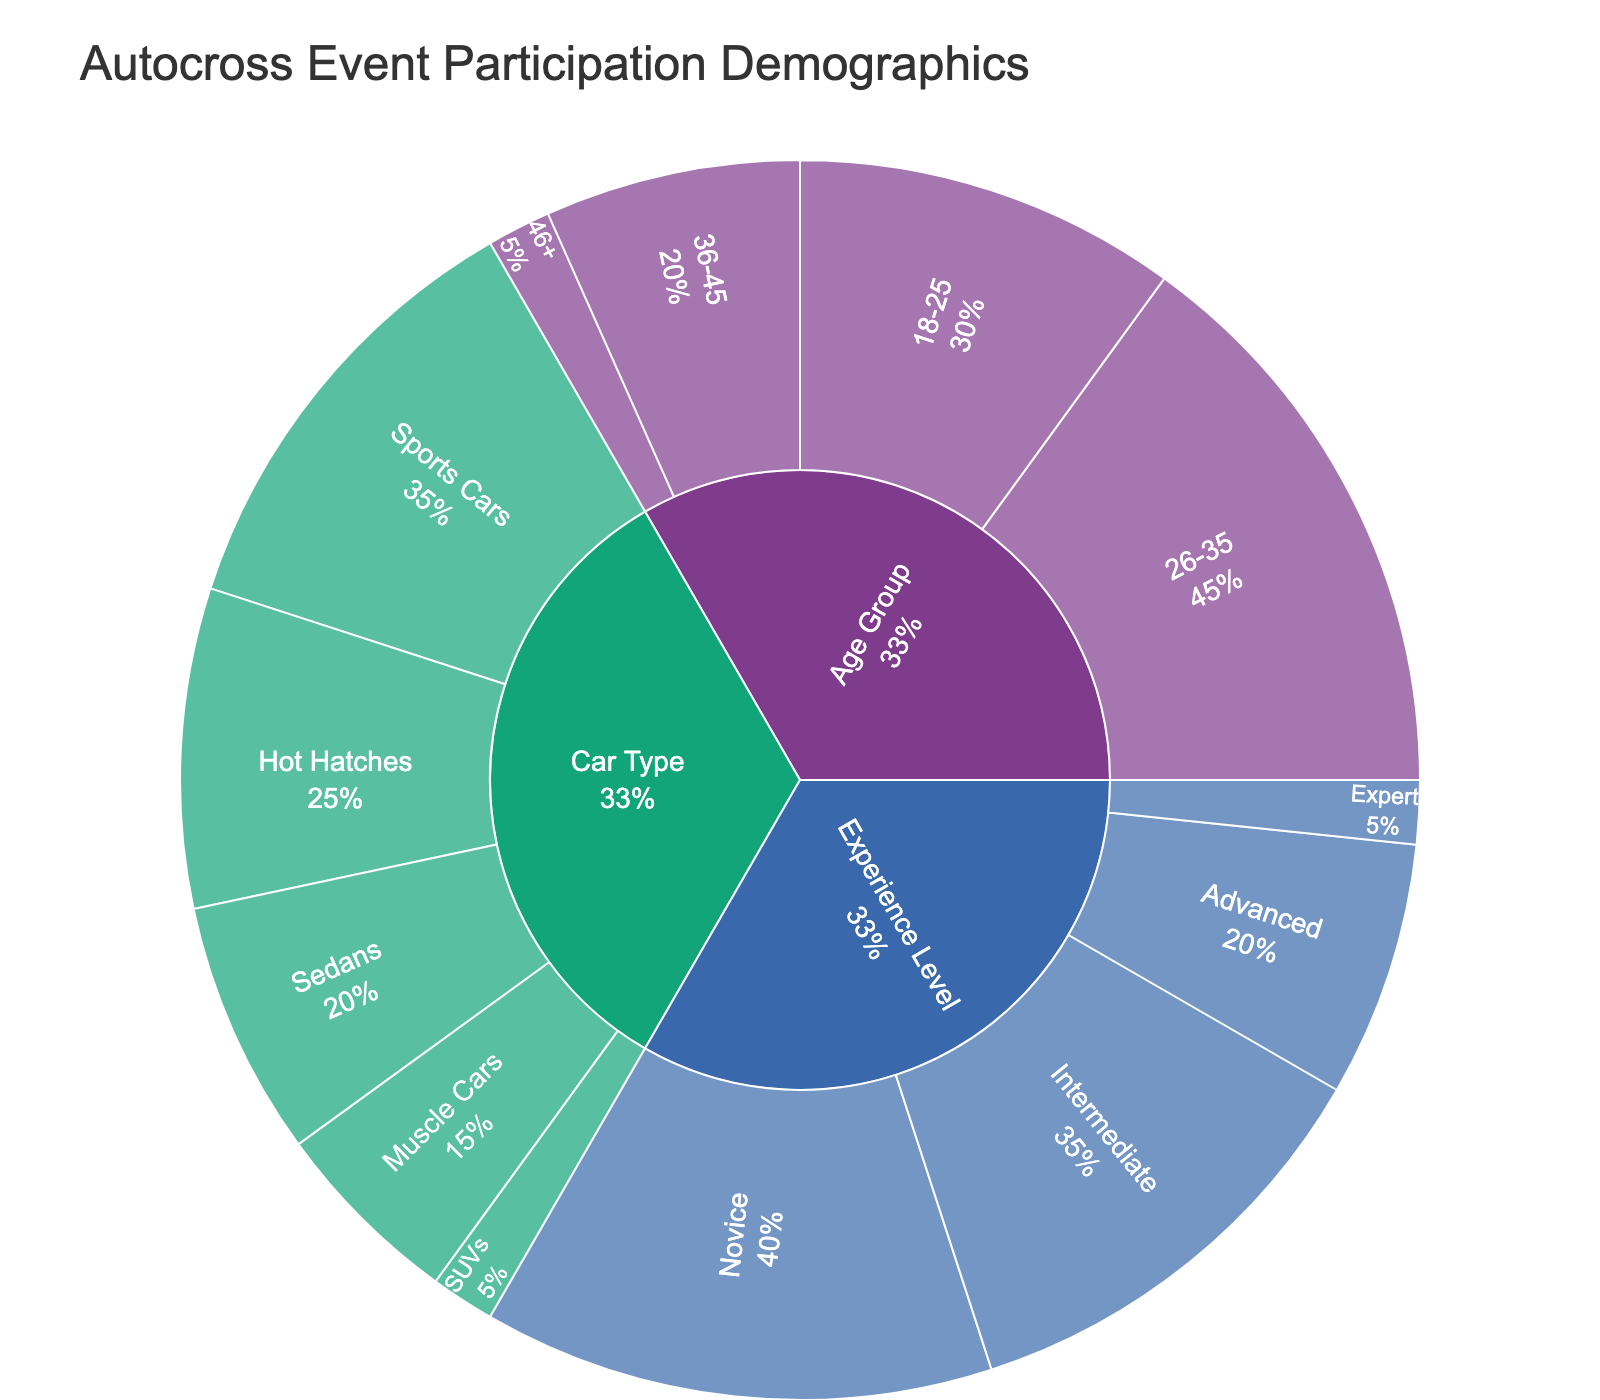What's the title of the plot? The title is usually displayed at the top center of the sunburst plot. In this case, it reads "Autocross Event Participation Demographics".
Answer: Autocross Event Participation Demographics What age group has the highest participation? Look at the sunburst plot section for Age Group and identify which segment has the largest size. The 26-35 group seems to be the largest.
Answer: 26-35 What's the difference in participation between the 18-25 and 46+ age groups? Identify the values for the 18-25 and 46+ age groups in the plot. Subtract the value for 46+ from the value for 18-25. 30 (18-25) - 5 (46+) = 25.
Answer: 25 Which experience level has the least participation? Look at the sunburst plot section for Experience Level and check the values for each segment. The smallest value belongs to the Expert level.
Answer: Expert How many people participate in muscle cars? Look at the sunburst plot section for Car Type and find the segment for Muscle Cars. The value shown is 15.
Answer: 15 What percentage of participants are Novices? Find the value for the Novice experience level and divide it by the total value of Experience Levels (40 (Novice) / (40 + 35 + 20 + 5) = 40 / 100 = 0.4). Multiply by 100 to get the percentage.
Answer: 40% Which car type has more participants: Sedans or Hot Hatches? Compare the values for Sedans and Hot Hatches in the Car Type section. Hot Hatches have 25, while Sedans have 20. Therefore, Hot Hatches have more participants.
Answer: Hot Hatches How do the distributions of car types compare to each other? Examine the segments in the Car Type section of the sunburst plot. Rank the car types from highest to lowest based on their values: Sports Cars (35), Hot Hatches (25), Sedans (20), Muscle Cars (15), SUVs (5).
Answer: Sports Cars > Hot Hatches > Sedans > Muscle Cars > SUVs What is the total number of participants across all experience levels? Add up the values for all experience levels: 40 (Novice) + 35 (Intermediate) + 20 (Advanced) + 5 (Expert) = 100.
Answer: 100 Which age group has a participation value closest to the total for Muscle Cars? Check the values for each age group and find the one closest to the 15 for Muscle Cars. The 36-45 age group has a value of 20, which is the closest.
Answer: 36-45 